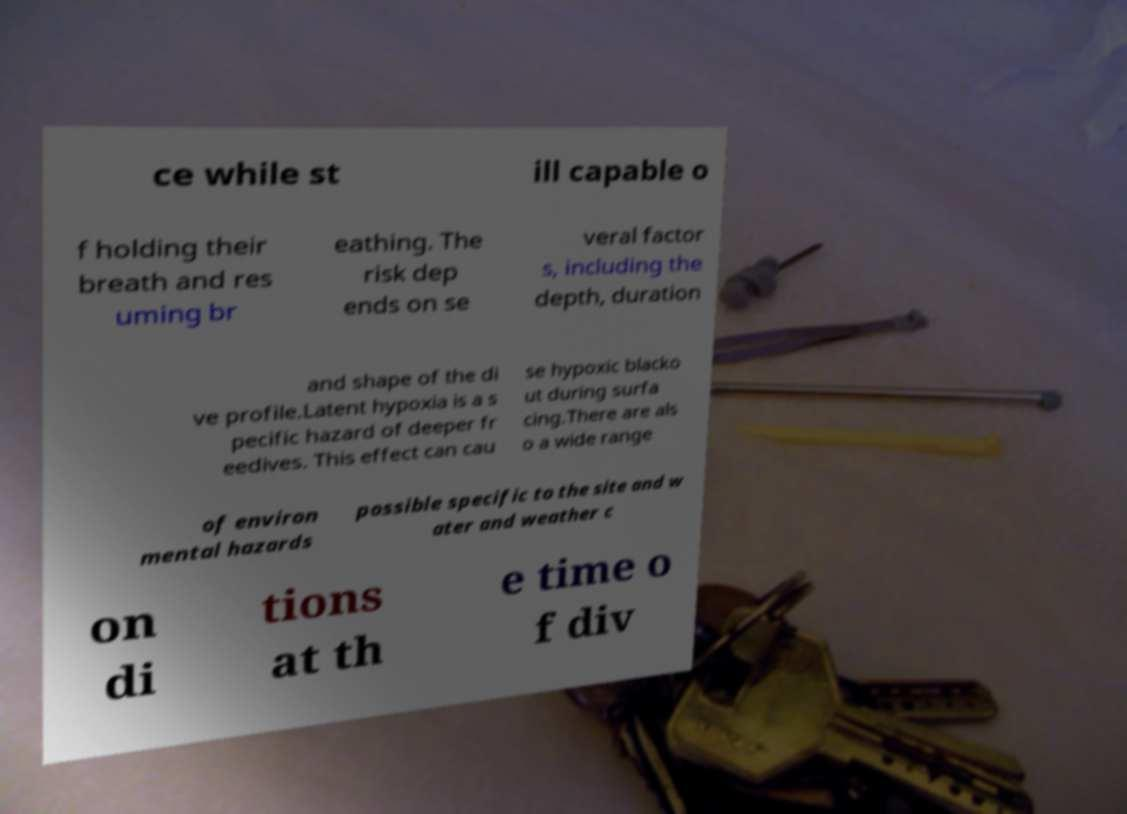Could you assist in decoding the text presented in this image and type it out clearly? ce while st ill capable o f holding their breath and res uming br eathing. The risk dep ends on se veral factor s, including the depth, duration and shape of the di ve profile.Latent hypoxia is a s pecific hazard of deeper fr eedives. This effect can cau se hypoxic blacko ut during surfa cing.There are als o a wide range of environ mental hazards possible specific to the site and w ater and weather c on di tions at th e time o f div 